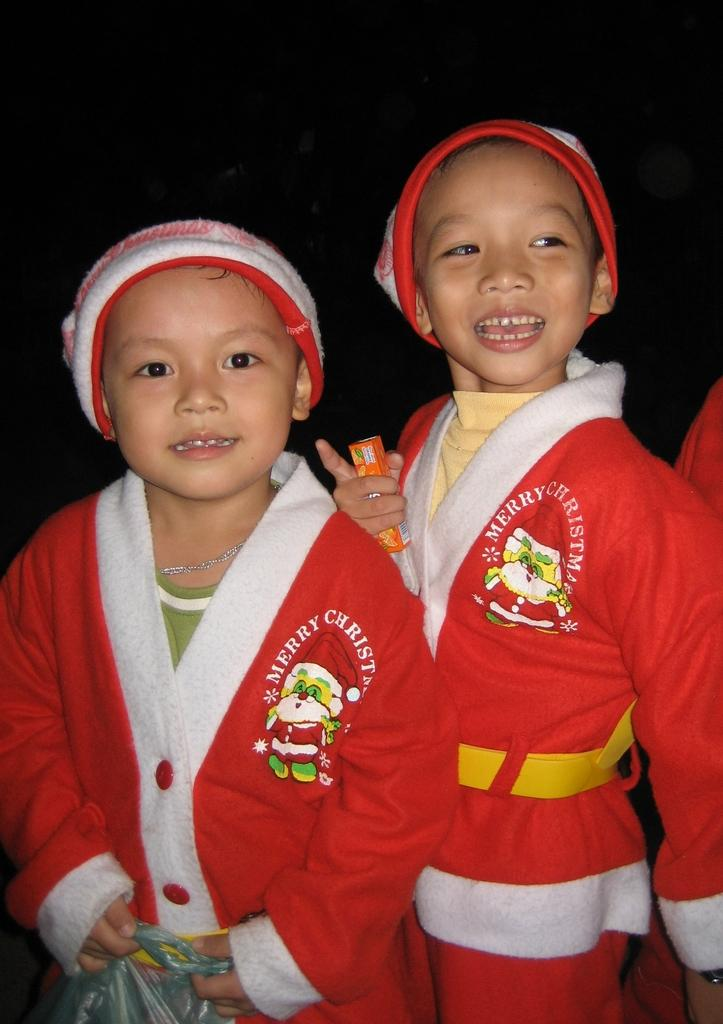<image>
Write a terse but informative summary of the picture. Two boys standing side by side wearing a sweater that says MERRY CHRISTMAS. 